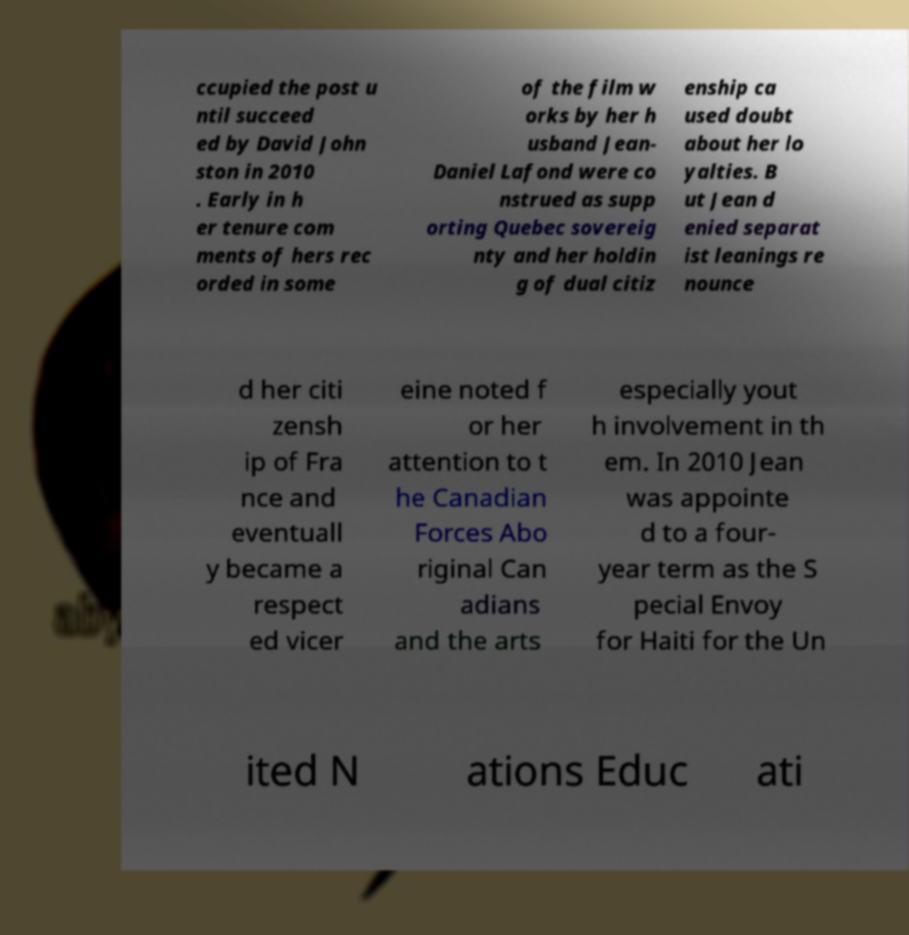Please identify and transcribe the text found in this image. ccupied the post u ntil succeed ed by David John ston in 2010 . Early in h er tenure com ments of hers rec orded in some of the film w orks by her h usband Jean- Daniel Lafond were co nstrued as supp orting Quebec sovereig nty and her holdin g of dual citiz enship ca used doubt about her lo yalties. B ut Jean d enied separat ist leanings re nounce d her citi zensh ip of Fra nce and eventuall y became a respect ed vicer eine noted f or her attention to t he Canadian Forces Abo riginal Can adians and the arts especially yout h involvement in th em. In 2010 Jean was appointe d to a four- year term as the S pecial Envoy for Haiti for the Un ited N ations Educ ati 